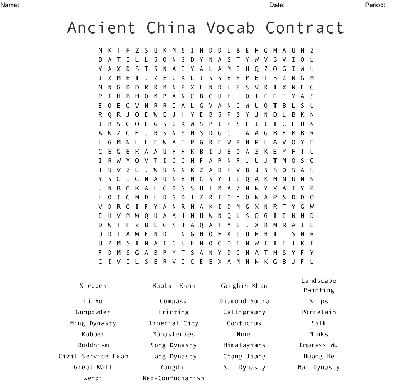Can you suggest some examples of philosophers mentioned in this word search? Sure! Look for 'Confucius,' who is pivotal to Chinese culture, as well as 'Laozi,' founder of Daoism. Both philosophers have profoundly influenced Asian thought and philosophy. 